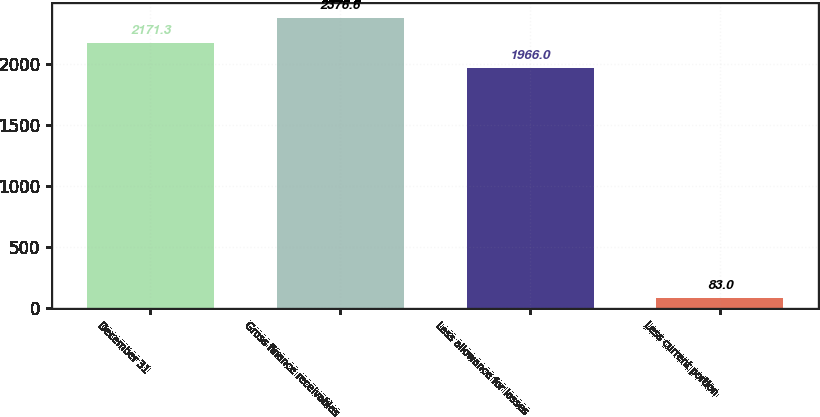Convert chart. <chart><loc_0><loc_0><loc_500><loc_500><bar_chart><fcel>December 31<fcel>Gross finance receivables<fcel>Less allowance for losses<fcel>Less current portion<nl><fcel>2171.3<fcel>2376.6<fcel>1966<fcel>83<nl></chart> 